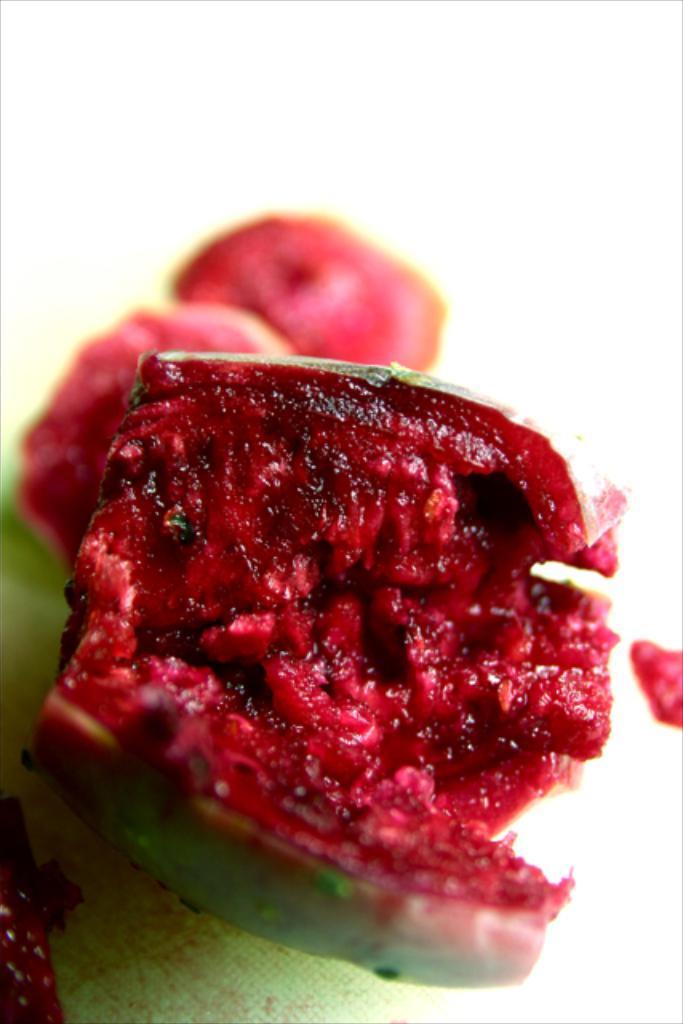Could you give a brief overview of what you see in this image? In this picture I can see the green and red color things in front and I see that it is white color in the background. 